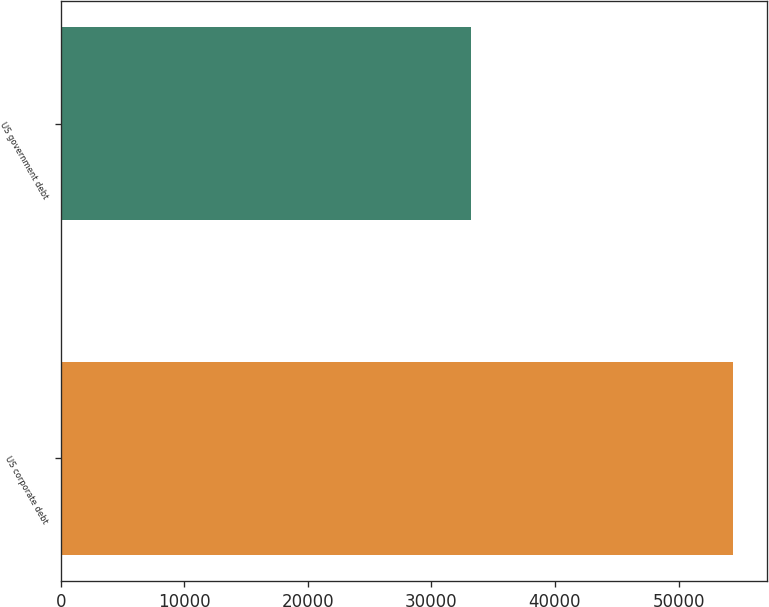<chart> <loc_0><loc_0><loc_500><loc_500><bar_chart><fcel>US corporate debt<fcel>US government debt<nl><fcel>54430<fcel>33188<nl></chart> 